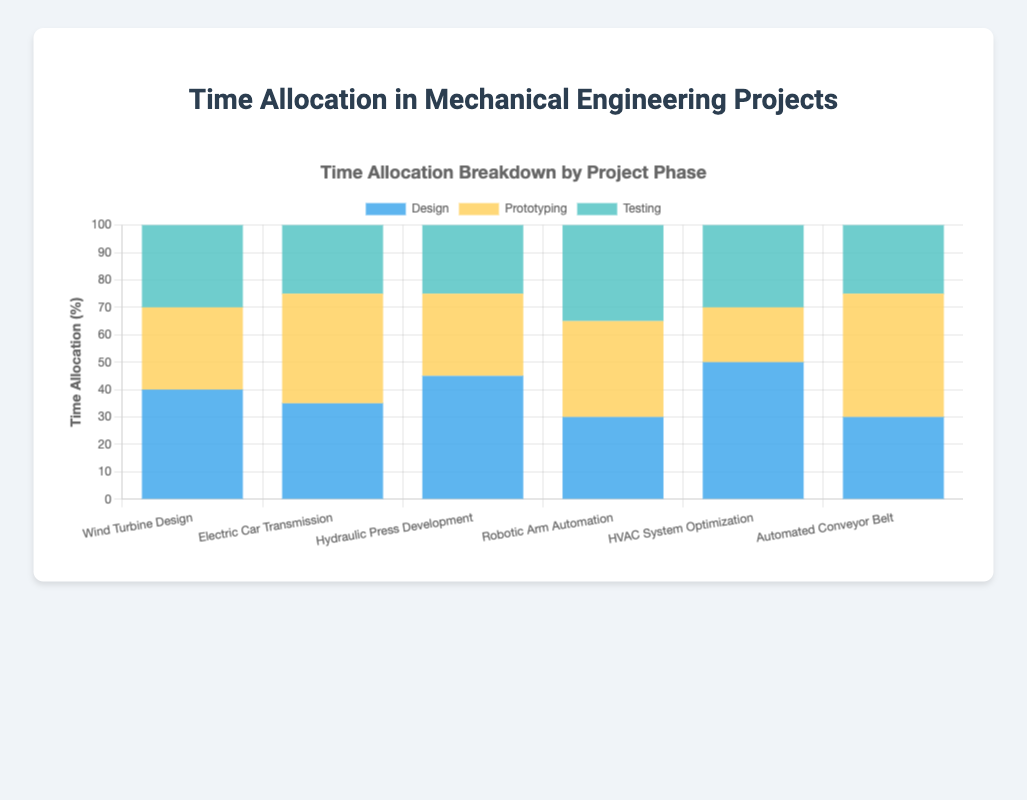Which project has the highest allocation of time for the design phase? Look at the bars representing the 'Design' phase for each project. The tallest bar indicates the highest allocation. The 'HVAC System Optimization' project has the tallest bar for the Design phase.
Answer: HVAC System Optimization Which project spends the least amount of time on prototyping? Look for the shortest bar representing the 'Prototyping' phase. The 'HVAC System Optimization' project has the shortest 'Prototyping' bar.
Answer: HVAC System Optimization Which two projects have the same time allocation for the testing phase? Compare the height of the bars representing the 'Testing' phase. Both 'Hydraulic Press Development' and 'Electric Car Transmission' have a 'Testing' bar height of 25%.
Answer: Hydraulic Press Development and Electric Car Transmission What is the total time spent on the design phase for 'Wind Turbine Design' and 'Electric Car Transmission' projects? Add the percentages of the 'Design' phase for both projects: 40% (Wind Turbine Design) + 35% (Electric Car Transmission) = 75%.
Answer: 75% How much more time does the 'Automated Conveyor Belt' project spend in prototyping compared to the 'Robotic Arm Automation' project? Subtract the 'Prototyping' phase time of 'Robotic Arm Automation' from 'Automated Conveyor Belt': 45% (Automated Conveyor Belt) - 35% (Robotic Arm Automation) = 10%.
Answer: 10% Which project has a balanced time allocation among the three phases? Look for a project where the bars for design, prototyping, and testing have roughly equal heights. The 'Robotic Arm Automation' project has a fairly balanced allocation with 30%, 35%, and 35%.
Answer: Robotic Arm Automation What is the average time spent on the testing phase across all projects? Sum all the 'Testing' phase percentages and divide by the number of projects: (30 + 25 + 25 + 35 + 30 + 25)/6 = 170/6 ≈ 28.33%.
Answer: 28.33% Which project has the most uneven distribution of time across the phases? Identify the project with the largest disparity among the heights of its bars. The 'HVAC System Optimization' project has a highly uneven distribution with 50% (Design), 20% (Prototyping), and 30% (Testing).
Answer: HVAC System Optimization 